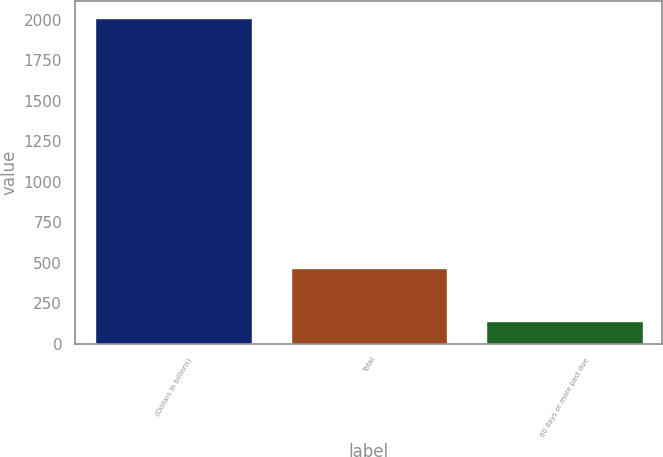Convert chart to OTSL. <chart><loc_0><loc_0><loc_500><loc_500><bar_chart><fcel>(Dollars in billions)<fcel>Total<fcel>60 days or more past due<nl><fcel>2012<fcel>467<fcel>137<nl></chart> 